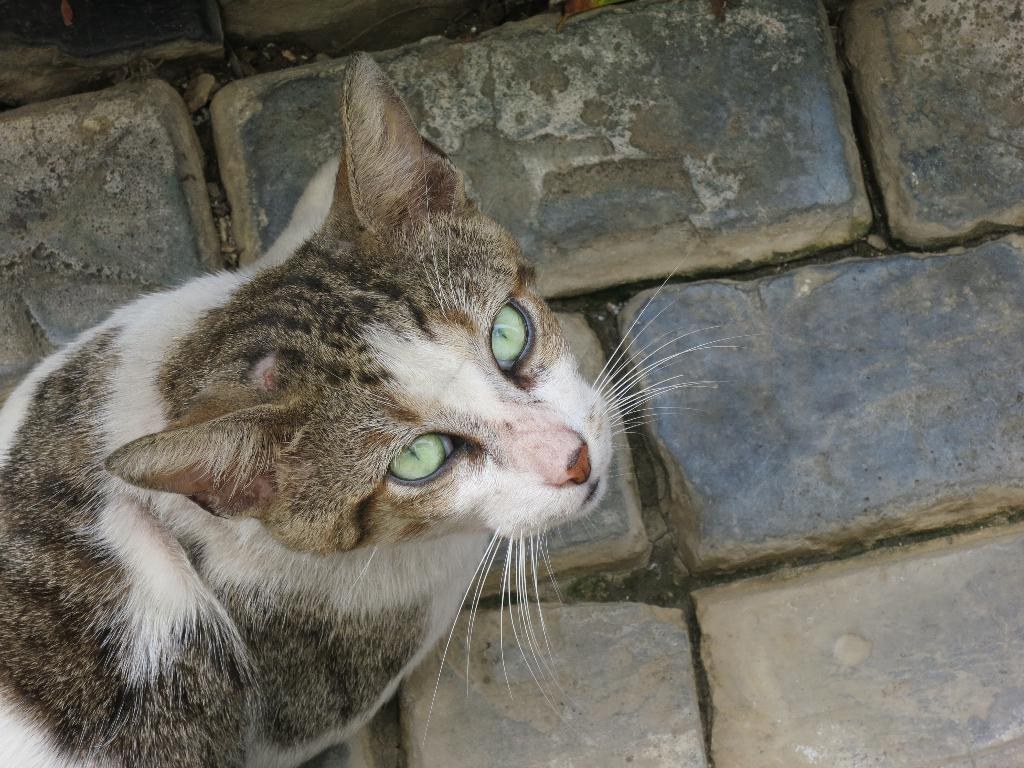What type of surface is visible in the image? There is a brick surface in the image. Can you describe any living creatures present in the image? Yes, there is a cat on the left side of the brick surface. What type of stitch is the cat using to sew a reaction from the family in the image? There is no stitch, reaction, or family present in the image; it only features a brick surface and a cat. 